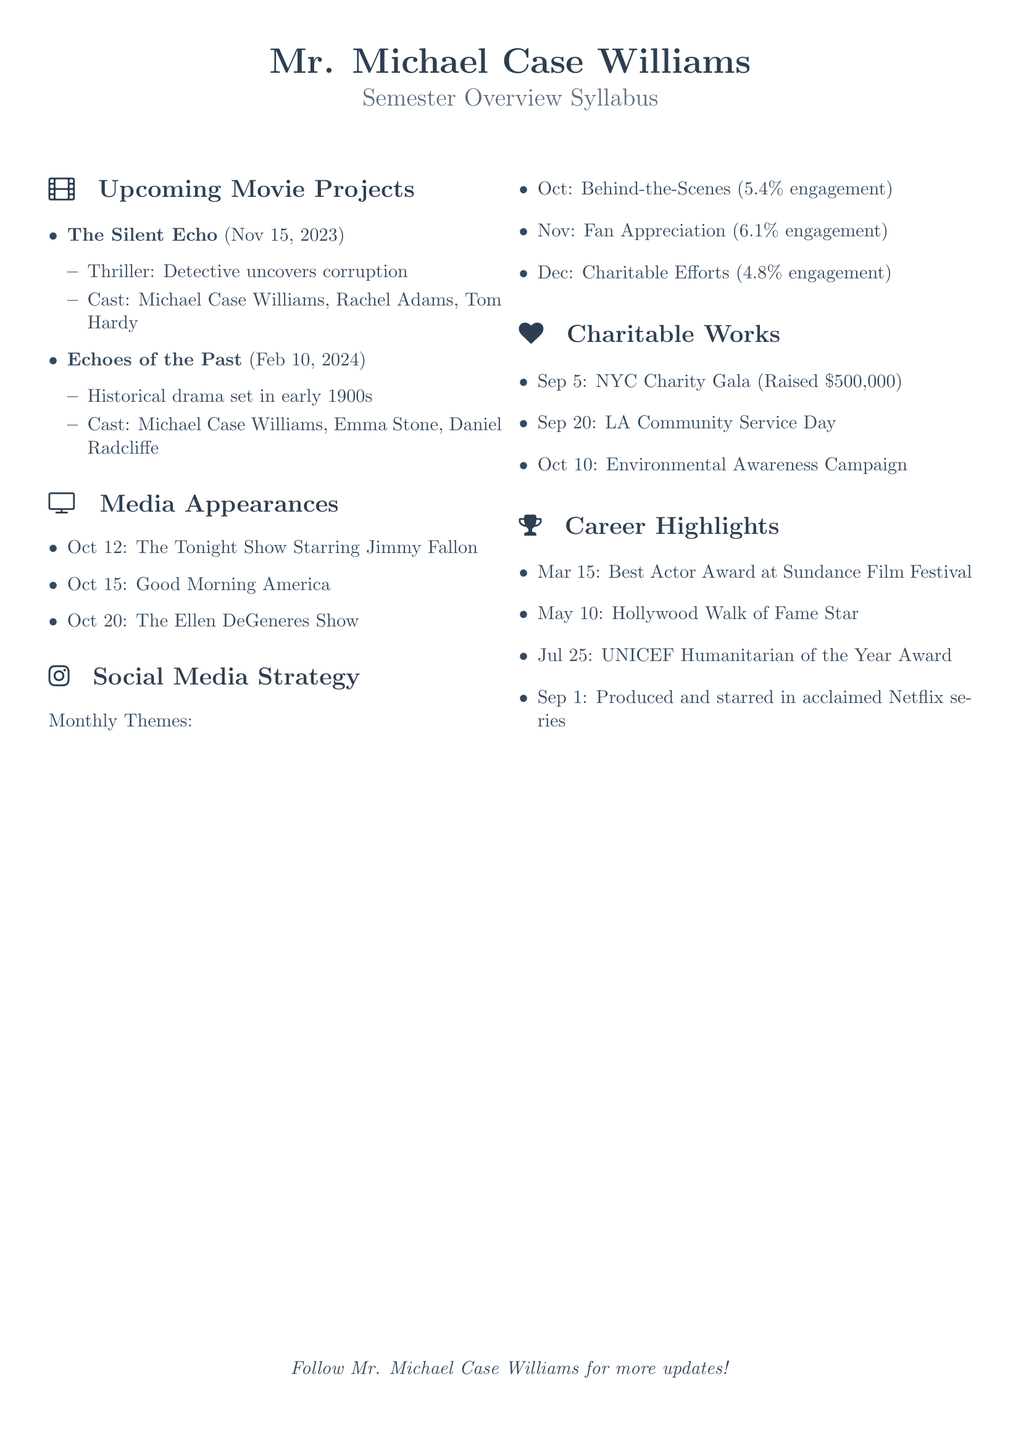what is the release date of "The Silent Echo"? "The Silent Echo" is scheduled to be released on November 15, 2023, as listed in the Upcoming Movie Projects section.
Answer: November 15, 2023 who are the cast members of "Echoes of the Past"? The cast members for "Echoes of the Past" are mentioned in the document: Michael Case Williams, Emma Stone, and Daniel Radcliffe.
Answer: Michael Case Williams, Emma Stone, Daniel Radcliffe how much money was raised at the NYC Charity Gala? The document states that the NYC Charity Gala raised \$500,000, which is specific information provided under Charitable Works.
Answer: \$500,000 which show is Mr. Michael Case Williams appearing on October 20? The document lists "The Ellen DeGeneres Show" as one of the media appearances on October 20.
Answer: The Ellen DeGeneres Show what was the engagement rate for the October social media theme? The engagement rate for the October theme, "Behind-the-Scenes," is noted as 5.4%.
Answer: 5.4% how many movies are listed in the Upcoming Movie Projects section? The document clearly states there are two movies mentioned in the Upcoming Movie Projects section.
Answer: Two which award did Mr. Michael Case Williams win at the Sundance Film Festival? The document specifies that he won the Best Actor Award at the Sundance Film Festival on March 15.
Answer: Best Actor Award what is the theme for November's social media strategy? The document describes the theme for November as "Fan Appreciation" under the Social Media Strategy section.
Answer: Fan Appreciation 